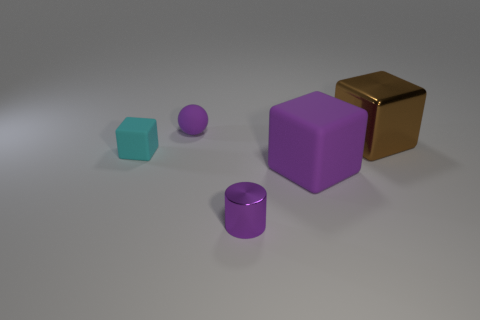Add 3 large yellow metal blocks. How many objects exist? 8 Subtract all cylinders. How many objects are left? 4 Subtract 0 cyan balls. How many objects are left? 5 Subtract all big purple matte blocks. Subtract all tiny purple things. How many objects are left? 2 Add 5 small matte spheres. How many small matte spheres are left? 6 Add 3 small things. How many small things exist? 6 